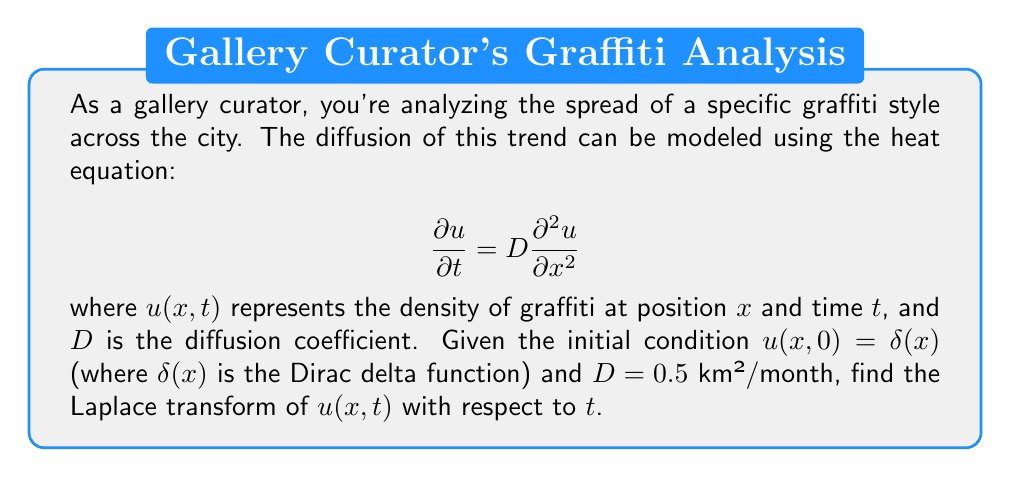Can you answer this question? To solve this problem, we'll follow these steps:

1) The heat equation in one dimension is given by:

   $$\frac{\partial u}{\partial t} = D\frac{\partial^2 u}{\partial x^2}$$

2) Taking the Laplace transform of both sides with respect to $t$, we get:

   $$s\bar{u}(x,s) - u(x,0) = D\frac{\partial^2 \bar{u}}{\partial x^2}$$

   where $\bar{u}(x,s)$ is the Laplace transform of $u(x,t)$.

3) Given the initial condition $u(x,0) = \delta(x)$, we can rewrite the equation as:

   $$s\bar{u}(x,s) - \delta(x) = D\frac{\partial^2 \bar{u}}{\partial x^2}$$

4) Rearranging the terms:

   $$D\frac{\partial^2 \bar{u}}{\partial x^2} - s\bar{u}(x,s) = -\delta(x)$$

5) This is a second-order ordinary differential equation. Its general solution is:

   $$\bar{u}(x,s) = A e^{-\sqrt{\frac{s}{D}}|x|} + B e^{\sqrt{\frac{s}{D}}|x|}$$

6) Due to the physical nature of the problem (the solution should decay as $x \to \pm\infty$), we can conclude that $B = 0$.

7) To find $A$, we integrate both sides of the equation from step 4 over a small interval around $x = 0$:

   $$\int_{-\epsilon}^{\epsilon} \left(D\frac{\partial^2 \bar{u}}{\partial x^2} - s\bar{u}(x,s)\right) dx = -\int_{-\epsilon}^{\epsilon} \delta(x) dx = -1$$

8) As $\epsilon \to 0$, the second term vanishes, and we're left with:

   $$D\left[\frac{\partial \bar{u}}{\partial x}\right]_{-\epsilon}^{\epsilon} = -1$$

9) Evaluating this using our solution from step 5:

   $$D\left(A\sqrt{\frac{s}{D}} + A\sqrt{\frac{s}{D}}\right) = 1$$

10) Solving for $A$:

    $$A = \frac{1}{2D\sqrt{\frac{s}{D}}} = \frac{1}{2\sqrt{Ds}}$$

11) Therefore, the final solution is:

    $$\bar{u}(x,s) = \frac{1}{2\sqrt{Ds}} e^{-\sqrt{\frac{s}{D}}|x|}$$

12) Substituting $D = 0.5$ km²/month:

    $$\bar{u}(x,s) = \frac{1}{2\sqrt{0.5s}} e^{-\sqrt{\frac{2s}{1}}|x|} = \frac{1}{\sqrt{2s}} e^{-\sqrt{2s}|x|}$$
Answer: $\bar{u}(x,s) = \frac{1}{\sqrt{2s}} e^{-\sqrt{2s}|x|}$ 